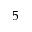Convert formula to latex. <formula><loc_0><loc_0><loc_500><loc_500>5</formula> 